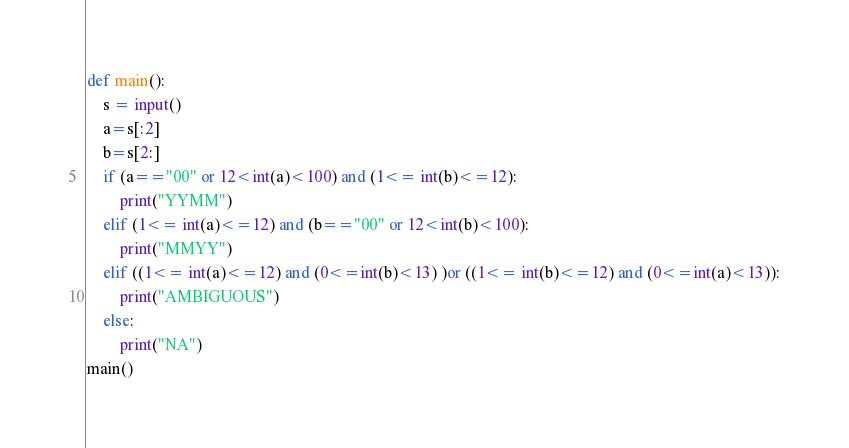Convert code to text. <code><loc_0><loc_0><loc_500><loc_500><_Python_>def main():
    s = input()
    a=s[:2]
    b=s[2:]
    if (a=="00" or 12<int(a)<100) and (1<= int(b)<=12):
        print("YYMM")
    elif (1<= int(a)<=12) and (b=="00" or 12<int(b)<100):
        print("MMYY")
    elif ((1<= int(a)<=12) and (0<=int(b)<13) )or ((1<= int(b)<=12) and (0<=int(a)<13)):
        print("AMBIGUOUS")
    else:
        print("NA")
main()</code> 